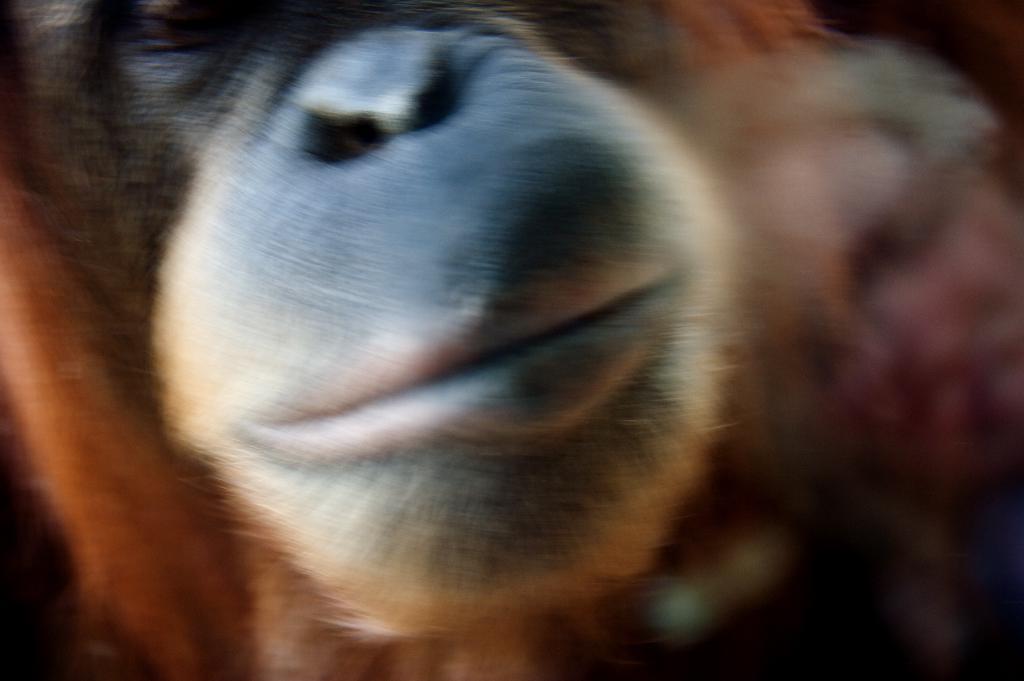How would you summarize this image in a sentence or two? In this image, we can see an animal. 